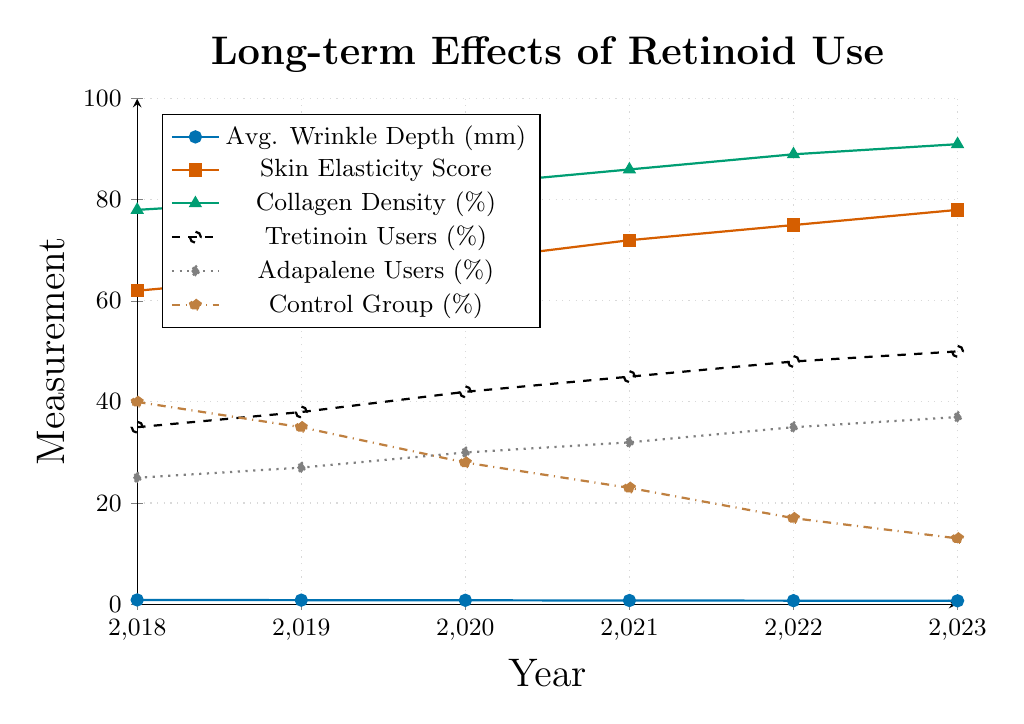Which year had the lowest average wrinkle depth? From the figure, observe the trend line for average wrinkle depth, which decreases over the years. The lowest point is in 2023.
Answer: 2023 How did the skin elasticity score change from 2018 to 2023? From the figure, note the skin elasticity scores for 2018 and 2023 (62 and 78, respectively). The difference is 78 - 62 = 16.
Answer: Increased by 16 What is the percentage increase in collagen density from 2019 to 2023? In 2019, collagen density is 80%, and in 2023 it's 91%. The percentage increase is ((91 - 80) / 80) * 100 = 13.75%.
Answer: 13.75% Compare the trend of Tretinoin users and Adapalene users from 2018 to 2023. Both percentages increase over the years. Tretinoin users rise from 35% to 50%, while Adapalene users climb from 25% to 37%. The increase rates are: Tretinoin users: 50 - 35 = 15, Adapalene users: 37 - 25 = 12.
Answer: Tretinoin users increase more than Adapalene users Which group shows a continuous decrease throughout the years? Look at the trend lines in the figure. The control group shows a consistent decrease from 40% in 2018 to 13% in 2023.
Answer: Control group What is the average collagen density over the given period? Sum the collagen density values from 2018 to 2023 (78 + 80 + 83 + 86 + 89 + 91) = 507. The average is 507 / 6 = 84.5%.
Answer: 84.5% How much did the average wrinkle depth decrease from 2018 to 2023? The values for average wrinkle depth in 2018 and 2023 are 0.82 mm and 0.65 mm, respectively. The decrease is 0.82 - 0.65 = 0.17 mm.
Answer: 0.17 mm In which year did the skin elasticity score surpass 70? From the figure, the skin elasticity score is 72 in 2021, which is the first year it surpasses 70.
Answer: 2021 Determine the rate of increase in the percentage of Tretinoin users from 2018 to 2023. The percentage of Tretinoin users increases from 35% in 2018 to 50% in 2023. The rate of increase is (50 - 35) / 35 * 100 = 42.86%.
Answer: 42.86% Which visual trend appears most significant in the figure? From a visual perspective, the control group's continual decrease from 40% to 13% is a significant trend. This descent is more drastic compared to other trends.
Answer: Control group's continuous decrease 